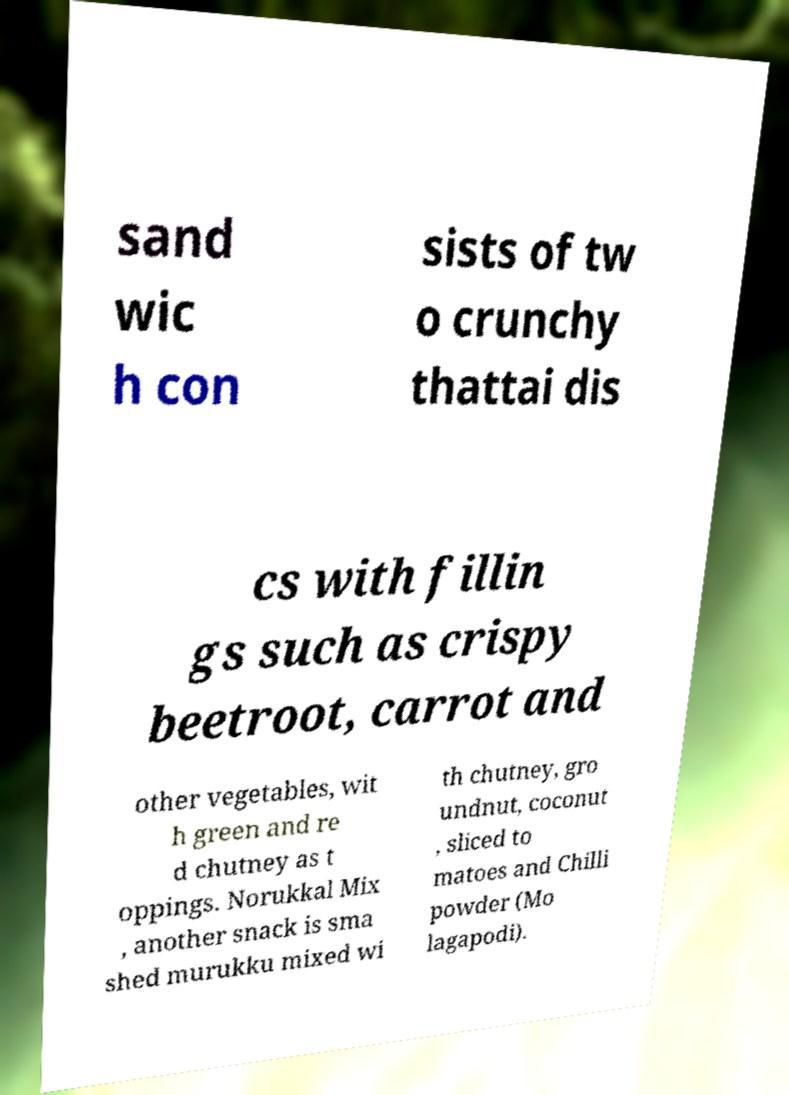Could you assist in decoding the text presented in this image and type it out clearly? sand wic h con sists of tw o crunchy thattai dis cs with fillin gs such as crispy beetroot, carrot and other vegetables, wit h green and re d chutney as t oppings. Norukkal Mix , another snack is sma shed murukku mixed wi th chutney, gro undnut, coconut , sliced to matoes and Chilli powder (Mo lagapodi). 